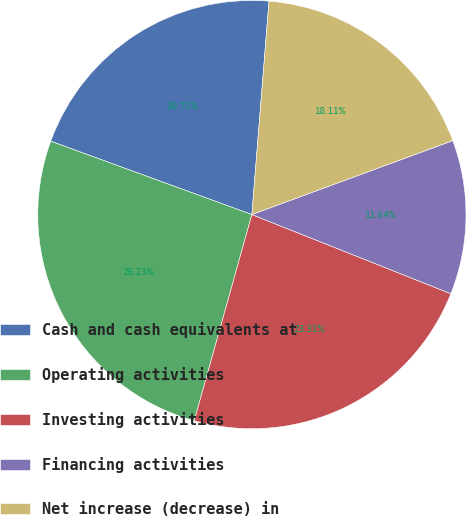Convert chart to OTSL. <chart><loc_0><loc_0><loc_500><loc_500><pie_chart><fcel>Cash and cash equivalents at<fcel>Operating activities<fcel>Investing activities<fcel>Financing activities<fcel>Net increase (decrease) in<nl><fcel>20.71%<fcel>26.23%<fcel>23.31%<fcel>11.64%<fcel>18.11%<nl></chart> 